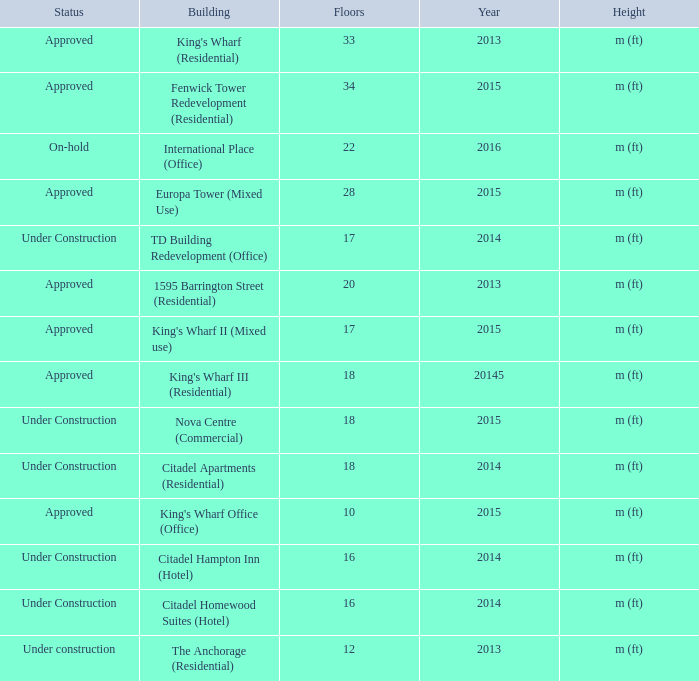What is the status of the building with more than 28 floor and a year of 2013? Approved. 